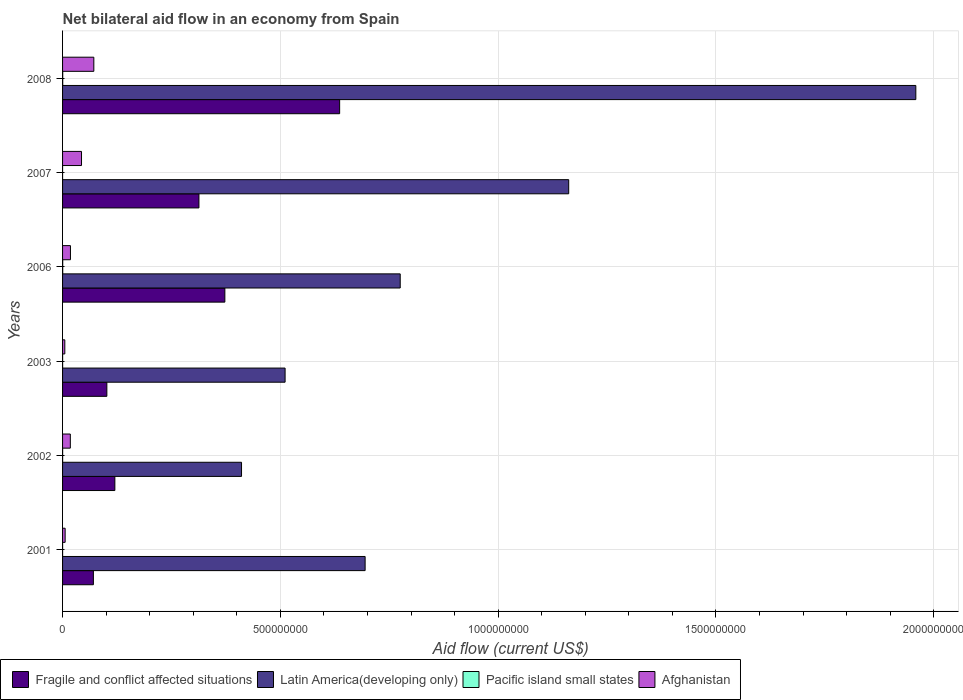How many groups of bars are there?
Give a very brief answer. 6. How many bars are there on the 2nd tick from the top?
Provide a succinct answer. 4. How many bars are there on the 5th tick from the bottom?
Make the answer very short. 4. In how many cases, is the number of bars for a given year not equal to the number of legend labels?
Keep it short and to the point. 0. What is the net bilateral aid flow in Pacific island small states in 2008?
Your response must be concise. 3.40e+05. Across all years, what is the maximum net bilateral aid flow in Afghanistan?
Ensure brevity in your answer.  7.18e+07. Across all years, what is the minimum net bilateral aid flow in Afghanistan?
Ensure brevity in your answer.  5.15e+06. In which year was the net bilateral aid flow in Pacific island small states maximum?
Make the answer very short. 2008. In which year was the net bilateral aid flow in Afghanistan minimum?
Give a very brief answer. 2003. What is the total net bilateral aid flow in Pacific island small states in the graph?
Give a very brief answer. 9.80e+05. What is the difference between the net bilateral aid flow in Afghanistan in 2001 and that in 2008?
Give a very brief answer. -6.59e+07. What is the difference between the net bilateral aid flow in Afghanistan in 2007 and the net bilateral aid flow in Fragile and conflict affected situations in 2003?
Offer a terse response. -5.82e+07. What is the average net bilateral aid flow in Latin America(developing only) per year?
Your response must be concise. 9.19e+08. In the year 2007, what is the difference between the net bilateral aid flow in Afghanistan and net bilateral aid flow in Pacific island small states?
Give a very brief answer. 4.35e+07. Is the net bilateral aid flow in Pacific island small states in 2003 less than that in 2008?
Make the answer very short. Yes. Is the difference between the net bilateral aid flow in Afghanistan in 2006 and 2007 greater than the difference between the net bilateral aid flow in Pacific island small states in 2006 and 2007?
Provide a short and direct response. No. What is the difference between the highest and the second highest net bilateral aid flow in Pacific island small states?
Keep it short and to the point. 10000. In how many years, is the net bilateral aid flow in Latin America(developing only) greater than the average net bilateral aid flow in Latin America(developing only) taken over all years?
Offer a terse response. 2. Is it the case that in every year, the sum of the net bilateral aid flow in Afghanistan and net bilateral aid flow in Pacific island small states is greater than the sum of net bilateral aid flow in Fragile and conflict affected situations and net bilateral aid flow in Latin America(developing only)?
Give a very brief answer. Yes. What does the 3rd bar from the top in 2007 represents?
Offer a terse response. Latin America(developing only). What does the 3rd bar from the bottom in 2001 represents?
Offer a very short reply. Pacific island small states. How many bars are there?
Make the answer very short. 24. How many years are there in the graph?
Offer a very short reply. 6. What is the difference between two consecutive major ticks on the X-axis?
Your response must be concise. 5.00e+08. Does the graph contain grids?
Ensure brevity in your answer.  Yes. What is the title of the graph?
Your response must be concise. Net bilateral aid flow in an economy from Spain. Does "High income: OECD" appear as one of the legend labels in the graph?
Your response must be concise. No. What is the Aid flow (current US$) in Fragile and conflict affected situations in 2001?
Keep it short and to the point. 7.08e+07. What is the Aid flow (current US$) in Latin America(developing only) in 2001?
Keep it short and to the point. 6.95e+08. What is the Aid flow (current US$) of Pacific island small states in 2001?
Your response must be concise. 5.00e+04. What is the Aid flow (current US$) of Afghanistan in 2001?
Provide a short and direct response. 5.92e+06. What is the Aid flow (current US$) in Fragile and conflict affected situations in 2002?
Your response must be concise. 1.20e+08. What is the Aid flow (current US$) in Latin America(developing only) in 2002?
Your response must be concise. 4.11e+08. What is the Aid flow (current US$) of Afghanistan in 2002?
Your answer should be very brief. 1.78e+07. What is the Aid flow (current US$) in Fragile and conflict affected situations in 2003?
Keep it short and to the point. 1.02e+08. What is the Aid flow (current US$) in Latin America(developing only) in 2003?
Your answer should be compact. 5.11e+08. What is the Aid flow (current US$) of Pacific island small states in 2003?
Make the answer very short. 1.00e+05. What is the Aid flow (current US$) in Afghanistan in 2003?
Keep it short and to the point. 5.15e+06. What is the Aid flow (current US$) of Fragile and conflict affected situations in 2006?
Your answer should be compact. 3.73e+08. What is the Aid flow (current US$) of Latin America(developing only) in 2006?
Make the answer very short. 7.75e+08. What is the Aid flow (current US$) in Pacific island small states in 2006?
Offer a very short reply. 3.30e+05. What is the Aid flow (current US$) in Afghanistan in 2006?
Your answer should be compact. 1.81e+07. What is the Aid flow (current US$) of Fragile and conflict affected situations in 2007?
Keep it short and to the point. 3.13e+08. What is the Aid flow (current US$) in Latin America(developing only) in 2007?
Give a very brief answer. 1.16e+09. What is the Aid flow (current US$) in Pacific island small states in 2007?
Make the answer very short. 10000. What is the Aid flow (current US$) in Afghanistan in 2007?
Your answer should be compact. 4.35e+07. What is the Aid flow (current US$) in Fragile and conflict affected situations in 2008?
Provide a short and direct response. 6.36e+08. What is the Aid flow (current US$) in Latin America(developing only) in 2008?
Your answer should be compact. 1.96e+09. What is the Aid flow (current US$) in Pacific island small states in 2008?
Your response must be concise. 3.40e+05. What is the Aid flow (current US$) in Afghanistan in 2008?
Provide a short and direct response. 7.18e+07. Across all years, what is the maximum Aid flow (current US$) in Fragile and conflict affected situations?
Make the answer very short. 6.36e+08. Across all years, what is the maximum Aid flow (current US$) in Latin America(developing only)?
Your answer should be very brief. 1.96e+09. Across all years, what is the maximum Aid flow (current US$) of Pacific island small states?
Give a very brief answer. 3.40e+05. Across all years, what is the maximum Aid flow (current US$) of Afghanistan?
Your response must be concise. 7.18e+07. Across all years, what is the minimum Aid flow (current US$) in Fragile and conflict affected situations?
Ensure brevity in your answer.  7.08e+07. Across all years, what is the minimum Aid flow (current US$) in Latin America(developing only)?
Keep it short and to the point. 4.11e+08. Across all years, what is the minimum Aid flow (current US$) of Afghanistan?
Offer a very short reply. 5.15e+06. What is the total Aid flow (current US$) of Fragile and conflict affected situations in the graph?
Make the answer very short. 1.61e+09. What is the total Aid flow (current US$) in Latin America(developing only) in the graph?
Offer a terse response. 5.51e+09. What is the total Aid flow (current US$) of Pacific island small states in the graph?
Provide a succinct answer. 9.80e+05. What is the total Aid flow (current US$) of Afghanistan in the graph?
Provide a succinct answer. 1.62e+08. What is the difference between the Aid flow (current US$) of Fragile and conflict affected situations in 2001 and that in 2002?
Give a very brief answer. -4.93e+07. What is the difference between the Aid flow (current US$) of Latin America(developing only) in 2001 and that in 2002?
Keep it short and to the point. 2.84e+08. What is the difference between the Aid flow (current US$) of Pacific island small states in 2001 and that in 2002?
Provide a succinct answer. -1.00e+05. What is the difference between the Aid flow (current US$) in Afghanistan in 2001 and that in 2002?
Your response must be concise. -1.19e+07. What is the difference between the Aid flow (current US$) in Fragile and conflict affected situations in 2001 and that in 2003?
Your answer should be compact. -3.09e+07. What is the difference between the Aid flow (current US$) in Latin America(developing only) in 2001 and that in 2003?
Your answer should be very brief. 1.84e+08. What is the difference between the Aid flow (current US$) of Pacific island small states in 2001 and that in 2003?
Offer a terse response. -5.00e+04. What is the difference between the Aid flow (current US$) in Afghanistan in 2001 and that in 2003?
Your answer should be compact. 7.70e+05. What is the difference between the Aid flow (current US$) in Fragile and conflict affected situations in 2001 and that in 2006?
Provide a short and direct response. -3.02e+08. What is the difference between the Aid flow (current US$) of Latin America(developing only) in 2001 and that in 2006?
Offer a very short reply. -8.06e+07. What is the difference between the Aid flow (current US$) of Pacific island small states in 2001 and that in 2006?
Offer a very short reply. -2.80e+05. What is the difference between the Aid flow (current US$) in Afghanistan in 2001 and that in 2006?
Give a very brief answer. -1.22e+07. What is the difference between the Aid flow (current US$) in Fragile and conflict affected situations in 2001 and that in 2007?
Your response must be concise. -2.42e+08. What is the difference between the Aid flow (current US$) in Latin America(developing only) in 2001 and that in 2007?
Your response must be concise. -4.67e+08. What is the difference between the Aid flow (current US$) in Afghanistan in 2001 and that in 2007?
Offer a very short reply. -3.76e+07. What is the difference between the Aid flow (current US$) of Fragile and conflict affected situations in 2001 and that in 2008?
Ensure brevity in your answer.  -5.65e+08. What is the difference between the Aid flow (current US$) in Latin America(developing only) in 2001 and that in 2008?
Your response must be concise. -1.26e+09. What is the difference between the Aid flow (current US$) in Afghanistan in 2001 and that in 2008?
Your answer should be compact. -6.59e+07. What is the difference between the Aid flow (current US$) in Fragile and conflict affected situations in 2002 and that in 2003?
Ensure brevity in your answer.  1.84e+07. What is the difference between the Aid flow (current US$) of Latin America(developing only) in 2002 and that in 2003?
Make the answer very short. -1.00e+08. What is the difference between the Aid flow (current US$) in Pacific island small states in 2002 and that in 2003?
Your answer should be compact. 5.00e+04. What is the difference between the Aid flow (current US$) in Afghanistan in 2002 and that in 2003?
Offer a terse response. 1.27e+07. What is the difference between the Aid flow (current US$) in Fragile and conflict affected situations in 2002 and that in 2006?
Make the answer very short. -2.53e+08. What is the difference between the Aid flow (current US$) in Latin America(developing only) in 2002 and that in 2006?
Keep it short and to the point. -3.64e+08. What is the difference between the Aid flow (current US$) of Afghanistan in 2002 and that in 2006?
Offer a terse response. -3.00e+05. What is the difference between the Aid flow (current US$) of Fragile and conflict affected situations in 2002 and that in 2007?
Keep it short and to the point. -1.93e+08. What is the difference between the Aid flow (current US$) in Latin America(developing only) in 2002 and that in 2007?
Keep it short and to the point. -7.51e+08. What is the difference between the Aid flow (current US$) in Pacific island small states in 2002 and that in 2007?
Provide a succinct answer. 1.40e+05. What is the difference between the Aid flow (current US$) in Afghanistan in 2002 and that in 2007?
Offer a very short reply. -2.57e+07. What is the difference between the Aid flow (current US$) of Fragile and conflict affected situations in 2002 and that in 2008?
Ensure brevity in your answer.  -5.16e+08. What is the difference between the Aid flow (current US$) in Latin America(developing only) in 2002 and that in 2008?
Keep it short and to the point. -1.55e+09. What is the difference between the Aid flow (current US$) of Afghanistan in 2002 and that in 2008?
Provide a short and direct response. -5.40e+07. What is the difference between the Aid flow (current US$) of Fragile and conflict affected situations in 2003 and that in 2006?
Ensure brevity in your answer.  -2.71e+08. What is the difference between the Aid flow (current US$) in Latin America(developing only) in 2003 and that in 2006?
Provide a succinct answer. -2.64e+08. What is the difference between the Aid flow (current US$) of Afghanistan in 2003 and that in 2006?
Provide a short and direct response. -1.30e+07. What is the difference between the Aid flow (current US$) in Fragile and conflict affected situations in 2003 and that in 2007?
Provide a succinct answer. -2.11e+08. What is the difference between the Aid flow (current US$) of Latin America(developing only) in 2003 and that in 2007?
Give a very brief answer. -6.51e+08. What is the difference between the Aid flow (current US$) of Afghanistan in 2003 and that in 2007?
Provide a short and direct response. -3.84e+07. What is the difference between the Aid flow (current US$) of Fragile and conflict affected situations in 2003 and that in 2008?
Make the answer very short. -5.34e+08. What is the difference between the Aid flow (current US$) in Latin America(developing only) in 2003 and that in 2008?
Offer a very short reply. -1.45e+09. What is the difference between the Aid flow (current US$) in Afghanistan in 2003 and that in 2008?
Provide a succinct answer. -6.66e+07. What is the difference between the Aid flow (current US$) of Fragile and conflict affected situations in 2006 and that in 2007?
Offer a very short reply. 5.95e+07. What is the difference between the Aid flow (current US$) in Latin America(developing only) in 2006 and that in 2007?
Offer a very short reply. -3.87e+08. What is the difference between the Aid flow (current US$) of Pacific island small states in 2006 and that in 2007?
Make the answer very short. 3.20e+05. What is the difference between the Aid flow (current US$) of Afghanistan in 2006 and that in 2007?
Your answer should be very brief. -2.54e+07. What is the difference between the Aid flow (current US$) in Fragile and conflict affected situations in 2006 and that in 2008?
Provide a succinct answer. -2.64e+08. What is the difference between the Aid flow (current US$) in Latin America(developing only) in 2006 and that in 2008?
Give a very brief answer. -1.18e+09. What is the difference between the Aid flow (current US$) of Pacific island small states in 2006 and that in 2008?
Provide a short and direct response. -10000. What is the difference between the Aid flow (current US$) of Afghanistan in 2006 and that in 2008?
Make the answer very short. -5.37e+07. What is the difference between the Aid flow (current US$) in Fragile and conflict affected situations in 2007 and that in 2008?
Keep it short and to the point. -3.23e+08. What is the difference between the Aid flow (current US$) in Latin America(developing only) in 2007 and that in 2008?
Provide a short and direct response. -7.97e+08. What is the difference between the Aid flow (current US$) in Pacific island small states in 2007 and that in 2008?
Give a very brief answer. -3.30e+05. What is the difference between the Aid flow (current US$) in Afghanistan in 2007 and that in 2008?
Provide a short and direct response. -2.83e+07. What is the difference between the Aid flow (current US$) of Fragile and conflict affected situations in 2001 and the Aid flow (current US$) of Latin America(developing only) in 2002?
Provide a short and direct response. -3.40e+08. What is the difference between the Aid flow (current US$) in Fragile and conflict affected situations in 2001 and the Aid flow (current US$) in Pacific island small states in 2002?
Provide a short and direct response. 7.06e+07. What is the difference between the Aid flow (current US$) of Fragile and conflict affected situations in 2001 and the Aid flow (current US$) of Afghanistan in 2002?
Your response must be concise. 5.30e+07. What is the difference between the Aid flow (current US$) in Latin America(developing only) in 2001 and the Aid flow (current US$) in Pacific island small states in 2002?
Your response must be concise. 6.95e+08. What is the difference between the Aid flow (current US$) of Latin America(developing only) in 2001 and the Aid flow (current US$) of Afghanistan in 2002?
Provide a succinct answer. 6.77e+08. What is the difference between the Aid flow (current US$) of Pacific island small states in 2001 and the Aid flow (current US$) of Afghanistan in 2002?
Keep it short and to the point. -1.78e+07. What is the difference between the Aid flow (current US$) of Fragile and conflict affected situations in 2001 and the Aid flow (current US$) of Latin America(developing only) in 2003?
Your answer should be compact. -4.40e+08. What is the difference between the Aid flow (current US$) of Fragile and conflict affected situations in 2001 and the Aid flow (current US$) of Pacific island small states in 2003?
Your response must be concise. 7.07e+07. What is the difference between the Aid flow (current US$) in Fragile and conflict affected situations in 2001 and the Aid flow (current US$) in Afghanistan in 2003?
Provide a succinct answer. 6.56e+07. What is the difference between the Aid flow (current US$) of Latin America(developing only) in 2001 and the Aid flow (current US$) of Pacific island small states in 2003?
Your response must be concise. 6.95e+08. What is the difference between the Aid flow (current US$) of Latin America(developing only) in 2001 and the Aid flow (current US$) of Afghanistan in 2003?
Provide a short and direct response. 6.90e+08. What is the difference between the Aid flow (current US$) in Pacific island small states in 2001 and the Aid flow (current US$) in Afghanistan in 2003?
Keep it short and to the point. -5.10e+06. What is the difference between the Aid flow (current US$) of Fragile and conflict affected situations in 2001 and the Aid flow (current US$) of Latin America(developing only) in 2006?
Provide a short and direct response. -7.04e+08. What is the difference between the Aid flow (current US$) in Fragile and conflict affected situations in 2001 and the Aid flow (current US$) in Pacific island small states in 2006?
Make the answer very short. 7.04e+07. What is the difference between the Aid flow (current US$) in Fragile and conflict affected situations in 2001 and the Aid flow (current US$) in Afghanistan in 2006?
Offer a terse response. 5.26e+07. What is the difference between the Aid flow (current US$) of Latin America(developing only) in 2001 and the Aid flow (current US$) of Pacific island small states in 2006?
Your answer should be very brief. 6.94e+08. What is the difference between the Aid flow (current US$) of Latin America(developing only) in 2001 and the Aid flow (current US$) of Afghanistan in 2006?
Give a very brief answer. 6.77e+08. What is the difference between the Aid flow (current US$) of Pacific island small states in 2001 and the Aid flow (current US$) of Afghanistan in 2006?
Your response must be concise. -1.81e+07. What is the difference between the Aid flow (current US$) of Fragile and conflict affected situations in 2001 and the Aid flow (current US$) of Latin America(developing only) in 2007?
Offer a terse response. -1.09e+09. What is the difference between the Aid flow (current US$) in Fragile and conflict affected situations in 2001 and the Aid flow (current US$) in Pacific island small states in 2007?
Ensure brevity in your answer.  7.08e+07. What is the difference between the Aid flow (current US$) of Fragile and conflict affected situations in 2001 and the Aid flow (current US$) of Afghanistan in 2007?
Provide a succinct answer. 2.73e+07. What is the difference between the Aid flow (current US$) in Latin America(developing only) in 2001 and the Aid flow (current US$) in Pacific island small states in 2007?
Give a very brief answer. 6.95e+08. What is the difference between the Aid flow (current US$) in Latin America(developing only) in 2001 and the Aid flow (current US$) in Afghanistan in 2007?
Ensure brevity in your answer.  6.51e+08. What is the difference between the Aid flow (current US$) of Pacific island small states in 2001 and the Aid flow (current US$) of Afghanistan in 2007?
Keep it short and to the point. -4.34e+07. What is the difference between the Aid flow (current US$) in Fragile and conflict affected situations in 2001 and the Aid flow (current US$) in Latin America(developing only) in 2008?
Offer a terse response. -1.89e+09. What is the difference between the Aid flow (current US$) of Fragile and conflict affected situations in 2001 and the Aid flow (current US$) of Pacific island small states in 2008?
Offer a very short reply. 7.04e+07. What is the difference between the Aid flow (current US$) in Fragile and conflict affected situations in 2001 and the Aid flow (current US$) in Afghanistan in 2008?
Provide a succinct answer. -1.03e+06. What is the difference between the Aid flow (current US$) of Latin America(developing only) in 2001 and the Aid flow (current US$) of Pacific island small states in 2008?
Ensure brevity in your answer.  6.94e+08. What is the difference between the Aid flow (current US$) in Latin America(developing only) in 2001 and the Aid flow (current US$) in Afghanistan in 2008?
Your response must be concise. 6.23e+08. What is the difference between the Aid flow (current US$) of Pacific island small states in 2001 and the Aid flow (current US$) of Afghanistan in 2008?
Provide a succinct answer. -7.17e+07. What is the difference between the Aid flow (current US$) of Fragile and conflict affected situations in 2002 and the Aid flow (current US$) of Latin America(developing only) in 2003?
Give a very brief answer. -3.91e+08. What is the difference between the Aid flow (current US$) in Fragile and conflict affected situations in 2002 and the Aid flow (current US$) in Pacific island small states in 2003?
Ensure brevity in your answer.  1.20e+08. What is the difference between the Aid flow (current US$) in Fragile and conflict affected situations in 2002 and the Aid flow (current US$) in Afghanistan in 2003?
Ensure brevity in your answer.  1.15e+08. What is the difference between the Aid flow (current US$) of Latin America(developing only) in 2002 and the Aid flow (current US$) of Pacific island small states in 2003?
Offer a terse response. 4.11e+08. What is the difference between the Aid flow (current US$) of Latin America(developing only) in 2002 and the Aid flow (current US$) of Afghanistan in 2003?
Provide a succinct answer. 4.06e+08. What is the difference between the Aid flow (current US$) in Pacific island small states in 2002 and the Aid flow (current US$) in Afghanistan in 2003?
Give a very brief answer. -5.00e+06. What is the difference between the Aid flow (current US$) of Fragile and conflict affected situations in 2002 and the Aid flow (current US$) of Latin America(developing only) in 2006?
Your answer should be very brief. -6.55e+08. What is the difference between the Aid flow (current US$) in Fragile and conflict affected situations in 2002 and the Aid flow (current US$) in Pacific island small states in 2006?
Give a very brief answer. 1.20e+08. What is the difference between the Aid flow (current US$) in Fragile and conflict affected situations in 2002 and the Aid flow (current US$) in Afghanistan in 2006?
Offer a very short reply. 1.02e+08. What is the difference between the Aid flow (current US$) of Latin America(developing only) in 2002 and the Aid flow (current US$) of Pacific island small states in 2006?
Provide a short and direct response. 4.11e+08. What is the difference between the Aid flow (current US$) of Latin America(developing only) in 2002 and the Aid flow (current US$) of Afghanistan in 2006?
Keep it short and to the point. 3.93e+08. What is the difference between the Aid flow (current US$) of Pacific island small states in 2002 and the Aid flow (current US$) of Afghanistan in 2006?
Your answer should be very brief. -1.80e+07. What is the difference between the Aid flow (current US$) of Fragile and conflict affected situations in 2002 and the Aid flow (current US$) of Latin America(developing only) in 2007?
Offer a terse response. -1.04e+09. What is the difference between the Aid flow (current US$) in Fragile and conflict affected situations in 2002 and the Aid flow (current US$) in Pacific island small states in 2007?
Provide a short and direct response. 1.20e+08. What is the difference between the Aid flow (current US$) in Fragile and conflict affected situations in 2002 and the Aid flow (current US$) in Afghanistan in 2007?
Offer a very short reply. 7.66e+07. What is the difference between the Aid flow (current US$) in Latin America(developing only) in 2002 and the Aid flow (current US$) in Pacific island small states in 2007?
Your response must be concise. 4.11e+08. What is the difference between the Aid flow (current US$) in Latin America(developing only) in 2002 and the Aid flow (current US$) in Afghanistan in 2007?
Your answer should be compact. 3.67e+08. What is the difference between the Aid flow (current US$) of Pacific island small states in 2002 and the Aid flow (current US$) of Afghanistan in 2007?
Provide a short and direct response. -4.34e+07. What is the difference between the Aid flow (current US$) in Fragile and conflict affected situations in 2002 and the Aid flow (current US$) in Latin America(developing only) in 2008?
Make the answer very short. -1.84e+09. What is the difference between the Aid flow (current US$) of Fragile and conflict affected situations in 2002 and the Aid flow (current US$) of Pacific island small states in 2008?
Provide a succinct answer. 1.20e+08. What is the difference between the Aid flow (current US$) in Fragile and conflict affected situations in 2002 and the Aid flow (current US$) in Afghanistan in 2008?
Offer a terse response. 4.83e+07. What is the difference between the Aid flow (current US$) of Latin America(developing only) in 2002 and the Aid flow (current US$) of Pacific island small states in 2008?
Provide a short and direct response. 4.11e+08. What is the difference between the Aid flow (current US$) of Latin America(developing only) in 2002 and the Aid flow (current US$) of Afghanistan in 2008?
Provide a short and direct response. 3.39e+08. What is the difference between the Aid flow (current US$) in Pacific island small states in 2002 and the Aid flow (current US$) in Afghanistan in 2008?
Provide a short and direct response. -7.16e+07. What is the difference between the Aid flow (current US$) of Fragile and conflict affected situations in 2003 and the Aid flow (current US$) of Latin America(developing only) in 2006?
Your response must be concise. -6.74e+08. What is the difference between the Aid flow (current US$) in Fragile and conflict affected situations in 2003 and the Aid flow (current US$) in Pacific island small states in 2006?
Make the answer very short. 1.01e+08. What is the difference between the Aid flow (current US$) in Fragile and conflict affected situations in 2003 and the Aid flow (current US$) in Afghanistan in 2006?
Keep it short and to the point. 8.36e+07. What is the difference between the Aid flow (current US$) in Latin America(developing only) in 2003 and the Aid flow (current US$) in Pacific island small states in 2006?
Keep it short and to the point. 5.11e+08. What is the difference between the Aid flow (current US$) in Latin America(developing only) in 2003 and the Aid flow (current US$) in Afghanistan in 2006?
Your answer should be compact. 4.93e+08. What is the difference between the Aid flow (current US$) in Pacific island small states in 2003 and the Aid flow (current US$) in Afghanistan in 2006?
Ensure brevity in your answer.  -1.80e+07. What is the difference between the Aid flow (current US$) of Fragile and conflict affected situations in 2003 and the Aid flow (current US$) of Latin America(developing only) in 2007?
Provide a succinct answer. -1.06e+09. What is the difference between the Aid flow (current US$) in Fragile and conflict affected situations in 2003 and the Aid flow (current US$) in Pacific island small states in 2007?
Keep it short and to the point. 1.02e+08. What is the difference between the Aid flow (current US$) of Fragile and conflict affected situations in 2003 and the Aid flow (current US$) of Afghanistan in 2007?
Make the answer very short. 5.82e+07. What is the difference between the Aid flow (current US$) in Latin America(developing only) in 2003 and the Aid flow (current US$) in Pacific island small states in 2007?
Make the answer very short. 5.11e+08. What is the difference between the Aid flow (current US$) of Latin America(developing only) in 2003 and the Aid flow (current US$) of Afghanistan in 2007?
Ensure brevity in your answer.  4.67e+08. What is the difference between the Aid flow (current US$) of Pacific island small states in 2003 and the Aid flow (current US$) of Afghanistan in 2007?
Your response must be concise. -4.34e+07. What is the difference between the Aid flow (current US$) in Fragile and conflict affected situations in 2003 and the Aid flow (current US$) in Latin America(developing only) in 2008?
Your answer should be compact. -1.86e+09. What is the difference between the Aid flow (current US$) in Fragile and conflict affected situations in 2003 and the Aid flow (current US$) in Pacific island small states in 2008?
Your answer should be compact. 1.01e+08. What is the difference between the Aid flow (current US$) of Fragile and conflict affected situations in 2003 and the Aid flow (current US$) of Afghanistan in 2008?
Your answer should be compact. 2.99e+07. What is the difference between the Aid flow (current US$) of Latin America(developing only) in 2003 and the Aid flow (current US$) of Pacific island small states in 2008?
Provide a short and direct response. 5.11e+08. What is the difference between the Aid flow (current US$) of Latin America(developing only) in 2003 and the Aid flow (current US$) of Afghanistan in 2008?
Your response must be concise. 4.39e+08. What is the difference between the Aid flow (current US$) in Pacific island small states in 2003 and the Aid flow (current US$) in Afghanistan in 2008?
Provide a short and direct response. -7.17e+07. What is the difference between the Aid flow (current US$) in Fragile and conflict affected situations in 2006 and the Aid flow (current US$) in Latin America(developing only) in 2007?
Your answer should be compact. -7.89e+08. What is the difference between the Aid flow (current US$) of Fragile and conflict affected situations in 2006 and the Aid flow (current US$) of Pacific island small states in 2007?
Make the answer very short. 3.73e+08. What is the difference between the Aid flow (current US$) in Fragile and conflict affected situations in 2006 and the Aid flow (current US$) in Afghanistan in 2007?
Ensure brevity in your answer.  3.29e+08. What is the difference between the Aid flow (current US$) in Latin America(developing only) in 2006 and the Aid flow (current US$) in Pacific island small states in 2007?
Your response must be concise. 7.75e+08. What is the difference between the Aid flow (current US$) in Latin America(developing only) in 2006 and the Aid flow (current US$) in Afghanistan in 2007?
Provide a short and direct response. 7.32e+08. What is the difference between the Aid flow (current US$) in Pacific island small states in 2006 and the Aid flow (current US$) in Afghanistan in 2007?
Your answer should be very brief. -4.32e+07. What is the difference between the Aid flow (current US$) of Fragile and conflict affected situations in 2006 and the Aid flow (current US$) of Latin America(developing only) in 2008?
Give a very brief answer. -1.59e+09. What is the difference between the Aid flow (current US$) of Fragile and conflict affected situations in 2006 and the Aid flow (current US$) of Pacific island small states in 2008?
Offer a terse response. 3.72e+08. What is the difference between the Aid flow (current US$) of Fragile and conflict affected situations in 2006 and the Aid flow (current US$) of Afghanistan in 2008?
Your answer should be very brief. 3.01e+08. What is the difference between the Aid flow (current US$) in Latin America(developing only) in 2006 and the Aid flow (current US$) in Pacific island small states in 2008?
Your answer should be compact. 7.75e+08. What is the difference between the Aid flow (current US$) in Latin America(developing only) in 2006 and the Aid flow (current US$) in Afghanistan in 2008?
Your response must be concise. 7.03e+08. What is the difference between the Aid flow (current US$) of Pacific island small states in 2006 and the Aid flow (current US$) of Afghanistan in 2008?
Your answer should be very brief. -7.15e+07. What is the difference between the Aid flow (current US$) of Fragile and conflict affected situations in 2007 and the Aid flow (current US$) of Latin America(developing only) in 2008?
Your response must be concise. -1.65e+09. What is the difference between the Aid flow (current US$) in Fragile and conflict affected situations in 2007 and the Aid flow (current US$) in Pacific island small states in 2008?
Offer a terse response. 3.13e+08. What is the difference between the Aid flow (current US$) of Fragile and conflict affected situations in 2007 and the Aid flow (current US$) of Afghanistan in 2008?
Make the answer very short. 2.41e+08. What is the difference between the Aid flow (current US$) in Latin America(developing only) in 2007 and the Aid flow (current US$) in Pacific island small states in 2008?
Your answer should be compact. 1.16e+09. What is the difference between the Aid flow (current US$) of Latin America(developing only) in 2007 and the Aid flow (current US$) of Afghanistan in 2008?
Make the answer very short. 1.09e+09. What is the difference between the Aid flow (current US$) in Pacific island small states in 2007 and the Aid flow (current US$) in Afghanistan in 2008?
Give a very brief answer. -7.18e+07. What is the average Aid flow (current US$) of Fragile and conflict affected situations per year?
Your response must be concise. 2.69e+08. What is the average Aid flow (current US$) in Latin America(developing only) per year?
Ensure brevity in your answer.  9.19e+08. What is the average Aid flow (current US$) in Pacific island small states per year?
Offer a very short reply. 1.63e+05. What is the average Aid flow (current US$) of Afghanistan per year?
Your answer should be compact. 2.70e+07. In the year 2001, what is the difference between the Aid flow (current US$) of Fragile and conflict affected situations and Aid flow (current US$) of Latin America(developing only)?
Your response must be concise. -6.24e+08. In the year 2001, what is the difference between the Aid flow (current US$) of Fragile and conflict affected situations and Aid flow (current US$) of Pacific island small states?
Keep it short and to the point. 7.07e+07. In the year 2001, what is the difference between the Aid flow (current US$) of Fragile and conflict affected situations and Aid flow (current US$) of Afghanistan?
Make the answer very short. 6.48e+07. In the year 2001, what is the difference between the Aid flow (current US$) of Latin America(developing only) and Aid flow (current US$) of Pacific island small states?
Keep it short and to the point. 6.95e+08. In the year 2001, what is the difference between the Aid flow (current US$) of Latin America(developing only) and Aid flow (current US$) of Afghanistan?
Your answer should be compact. 6.89e+08. In the year 2001, what is the difference between the Aid flow (current US$) in Pacific island small states and Aid flow (current US$) in Afghanistan?
Your answer should be compact. -5.87e+06. In the year 2002, what is the difference between the Aid flow (current US$) in Fragile and conflict affected situations and Aid flow (current US$) in Latin America(developing only)?
Offer a terse response. -2.91e+08. In the year 2002, what is the difference between the Aid flow (current US$) in Fragile and conflict affected situations and Aid flow (current US$) in Pacific island small states?
Offer a very short reply. 1.20e+08. In the year 2002, what is the difference between the Aid flow (current US$) in Fragile and conflict affected situations and Aid flow (current US$) in Afghanistan?
Keep it short and to the point. 1.02e+08. In the year 2002, what is the difference between the Aid flow (current US$) of Latin America(developing only) and Aid flow (current US$) of Pacific island small states?
Make the answer very short. 4.11e+08. In the year 2002, what is the difference between the Aid flow (current US$) of Latin America(developing only) and Aid flow (current US$) of Afghanistan?
Keep it short and to the point. 3.93e+08. In the year 2002, what is the difference between the Aid flow (current US$) of Pacific island small states and Aid flow (current US$) of Afghanistan?
Offer a very short reply. -1.77e+07. In the year 2003, what is the difference between the Aid flow (current US$) of Fragile and conflict affected situations and Aid flow (current US$) of Latin America(developing only)?
Offer a very short reply. -4.09e+08. In the year 2003, what is the difference between the Aid flow (current US$) in Fragile and conflict affected situations and Aid flow (current US$) in Pacific island small states?
Your answer should be very brief. 1.02e+08. In the year 2003, what is the difference between the Aid flow (current US$) of Fragile and conflict affected situations and Aid flow (current US$) of Afghanistan?
Provide a short and direct response. 9.65e+07. In the year 2003, what is the difference between the Aid flow (current US$) in Latin America(developing only) and Aid flow (current US$) in Pacific island small states?
Provide a short and direct response. 5.11e+08. In the year 2003, what is the difference between the Aid flow (current US$) in Latin America(developing only) and Aid flow (current US$) in Afghanistan?
Give a very brief answer. 5.06e+08. In the year 2003, what is the difference between the Aid flow (current US$) of Pacific island small states and Aid flow (current US$) of Afghanistan?
Provide a succinct answer. -5.05e+06. In the year 2006, what is the difference between the Aid flow (current US$) in Fragile and conflict affected situations and Aid flow (current US$) in Latin America(developing only)?
Offer a terse response. -4.03e+08. In the year 2006, what is the difference between the Aid flow (current US$) in Fragile and conflict affected situations and Aid flow (current US$) in Pacific island small states?
Offer a very short reply. 3.72e+08. In the year 2006, what is the difference between the Aid flow (current US$) in Fragile and conflict affected situations and Aid flow (current US$) in Afghanistan?
Provide a succinct answer. 3.55e+08. In the year 2006, what is the difference between the Aid flow (current US$) of Latin America(developing only) and Aid flow (current US$) of Pacific island small states?
Provide a short and direct response. 7.75e+08. In the year 2006, what is the difference between the Aid flow (current US$) in Latin America(developing only) and Aid flow (current US$) in Afghanistan?
Your response must be concise. 7.57e+08. In the year 2006, what is the difference between the Aid flow (current US$) of Pacific island small states and Aid flow (current US$) of Afghanistan?
Offer a terse response. -1.78e+07. In the year 2007, what is the difference between the Aid flow (current US$) in Fragile and conflict affected situations and Aid flow (current US$) in Latin America(developing only)?
Provide a succinct answer. -8.49e+08. In the year 2007, what is the difference between the Aid flow (current US$) in Fragile and conflict affected situations and Aid flow (current US$) in Pacific island small states?
Give a very brief answer. 3.13e+08. In the year 2007, what is the difference between the Aid flow (current US$) in Fragile and conflict affected situations and Aid flow (current US$) in Afghanistan?
Give a very brief answer. 2.70e+08. In the year 2007, what is the difference between the Aid flow (current US$) of Latin America(developing only) and Aid flow (current US$) of Pacific island small states?
Provide a succinct answer. 1.16e+09. In the year 2007, what is the difference between the Aid flow (current US$) in Latin America(developing only) and Aid flow (current US$) in Afghanistan?
Your response must be concise. 1.12e+09. In the year 2007, what is the difference between the Aid flow (current US$) of Pacific island small states and Aid flow (current US$) of Afghanistan?
Ensure brevity in your answer.  -4.35e+07. In the year 2008, what is the difference between the Aid flow (current US$) of Fragile and conflict affected situations and Aid flow (current US$) of Latin America(developing only)?
Provide a short and direct response. -1.32e+09. In the year 2008, what is the difference between the Aid flow (current US$) of Fragile and conflict affected situations and Aid flow (current US$) of Pacific island small states?
Your response must be concise. 6.36e+08. In the year 2008, what is the difference between the Aid flow (current US$) of Fragile and conflict affected situations and Aid flow (current US$) of Afghanistan?
Your answer should be compact. 5.64e+08. In the year 2008, what is the difference between the Aid flow (current US$) in Latin America(developing only) and Aid flow (current US$) in Pacific island small states?
Your response must be concise. 1.96e+09. In the year 2008, what is the difference between the Aid flow (current US$) in Latin America(developing only) and Aid flow (current US$) in Afghanistan?
Ensure brevity in your answer.  1.89e+09. In the year 2008, what is the difference between the Aid flow (current US$) of Pacific island small states and Aid flow (current US$) of Afghanistan?
Offer a terse response. -7.14e+07. What is the ratio of the Aid flow (current US$) of Fragile and conflict affected situations in 2001 to that in 2002?
Your response must be concise. 0.59. What is the ratio of the Aid flow (current US$) in Latin America(developing only) in 2001 to that in 2002?
Your response must be concise. 1.69. What is the ratio of the Aid flow (current US$) of Pacific island small states in 2001 to that in 2002?
Make the answer very short. 0.33. What is the ratio of the Aid flow (current US$) in Afghanistan in 2001 to that in 2002?
Provide a short and direct response. 0.33. What is the ratio of the Aid flow (current US$) in Fragile and conflict affected situations in 2001 to that in 2003?
Provide a succinct answer. 0.7. What is the ratio of the Aid flow (current US$) of Latin America(developing only) in 2001 to that in 2003?
Make the answer very short. 1.36. What is the ratio of the Aid flow (current US$) of Pacific island small states in 2001 to that in 2003?
Keep it short and to the point. 0.5. What is the ratio of the Aid flow (current US$) of Afghanistan in 2001 to that in 2003?
Keep it short and to the point. 1.15. What is the ratio of the Aid flow (current US$) of Fragile and conflict affected situations in 2001 to that in 2006?
Ensure brevity in your answer.  0.19. What is the ratio of the Aid flow (current US$) in Latin America(developing only) in 2001 to that in 2006?
Make the answer very short. 0.9. What is the ratio of the Aid flow (current US$) in Pacific island small states in 2001 to that in 2006?
Your response must be concise. 0.15. What is the ratio of the Aid flow (current US$) in Afghanistan in 2001 to that in 2006?
Your answer should be compact. 0.33. What is the ratio of the Aid flow (current US$) in Fragile and conflict affected situations in 2001 to that in 2007?
Give a very brief answer. 0.23. What is the ratio of the Aid flow (current US$) of Latin America(developing only) in 2001 to that in 2007?
Your response must be concise. 0.6. What is the ratio of the Aid flow (current US$) in Afghanistan in 2001 to that in 2007?
Offer a very short reply. 0.14. What is the ratio of the Aid flow (current US$) in Fragile and conflict affected situations in 2001 to that in 2008?
Provide a short and direct response. 0.11. What is the ratio of the Aid flow (current US$) of Latin America(developing only) in 2001 to that in 2008?
Offer a very short reply. 0.35. What is the ratio of the Aid flow (current US$) in Pacific island small states in 2001 to that in 2008?
Your response must be concise. 0.15. What is the ratio of the Aid flow (current US$) in Afghanistan in 2001 to that in 2008?
Your answer should be compact. 0.08. What is the ratio of the Aid flow (current US$) of Fragile and conflict affected situations in 2002 to that in 2003?
Offer a very short reply. 1.18. What is the ratio of the Aid flow (current US$) of Latin America(developing only) in 2002 to that in 2003?
Your answer should be very brief. 0.8. What is the ratio of the Aid flow (current US$) of Afghanistan in 2002 to that in 2003?
Make the answer very short. 3.46. What is the ratio of the Aid flow (current US$) of Fragile and conflict affected situations in 2002 to that in 2006?
Provide a succinct answer. 0.32. What is the ratio of the Aid flow (current US$) in Latin America(developing only) in 2002 to that in 2006?
Provide a short and direct response. 0.53. What is the ratio of the Aid flow (current US$) in Pacific island small states in 2002 to that in 2006?
Provide a succinct answer. 0.45. What is the ratio of the Aid flow (current US$) in Afghanistan in 2002 to that in 2006?
Your answer should be compact. 0.98. What is the ratio of the Aid flow (current US$) of Fragile and conflict affected situations in 2002 to that in 2007?
Your answer should be very brief. 0.38. What is the ratio of the Aid flow (current US$) of Latin America(developing only) in 2002 to that in 2007?
Provide a succinct answer. 0.35. What is the ratio of the Aid flow (current US$) of Afghanistan in 2002 to that in 2007?
Provide a succinct answer. 0.41. What is the ratio of the Aid flow (current US$) in Fragile and conflict affected situations in 2002 to that in 2008?
Ensure brevity in your answer.  0.19. What is the ratio of the Aid flow (current US$) of Latin America(developing only) in 2002 to that in 2008?
Make the answer very short. 0.21. What is the ratio of the Aid flow (current US$) of Pacific island small states in 2002 to that in 2008?
Ensure brevity in your answer.  0.44. What is the ratio of the Aid flow (current US$) in Afghanistan in 2002 to that in 2008?
Offer a very short reply. 0.25. What is the ratio of the Aid flow (current US$) in Fragile and conflict affected situations in 2003 to that in 2006?
Provide a short and direct response. 0.27. What is the ratio of the Aid flow (current US$) of Latin America(developing only) in 2003 to that in 2006?
Your answer should be compact. 0.66. What is the ratio of the Aid flow (current US$) of Pacific island small states in 2003 to that in 2006?
Provide a succinct answer. 0.3. What is the ratio of the Aid flow (current US$) of Afghanistan in 2003 to that in 2006?
Provide a short and direct response. 0.28. What is the ratio of the Aid flow (current US$) in Fragile and conflict affected situations in 2003 to that in 2007?
Keep it short and to the point. 0.32. What is the ratio of the Aid flow (current US$) of Latin America(developing only) in 2003 to that in 2007?
Provide a short and direct response. 0.44. What is the ratio of the Aid flow (current US$) of Pacific island small states in 2003 to that in 2007?
Give a very brief answer. 10. What is the ratio of the Aid flow (current US$) of Afghanistan in 2003 to that in 2007?
Ensure brevity in your answer.  0.12. What is the ratio of the Aid flow (current US$) of Fragile and conflict affected situations in 2003 to that in 2008?
Offer a very short reply. 0.16. What is the ratio of the Aid flow (current US$) in Latin America(developing only) in 2003 to that in 2008?
Keep it short and to the point. 0.26. What is the ratio of the Aid flow (current US$) in Pacific island small states in 2003 to that in 2008?
Ensure brevity in your answer.  0.29. What is the ratio of the Aid flow (current US$) in Afghanistan in 2003 to that in 2008?
Offer a terse response. 0.07. What is the ratio of the Aid flow (current US$) of Fragile and conflict affected situations in 2006 to that in 2007?
Provide a succinct answer. 1.19. What is the ratio of the Aid flow (current US$) in Latin America(developing only) in 2006 to that in 2007?
Offer a terse response. 0.67. What is the ratio of the Aid flow (current US$) in Pacific island small states in 2006 to that in 2007?
Make the answer very short. 33. What is the ratio of the Aid flow (current US$) in Afghanistan in 2006 to that in 2007?
Your response must be concise. 0.42. What is the ratio of the Aid flow (current US$) in Fragile and conflict affected situations in 2006 to that in 2008?
Give a very brief answer. 0.59. What is the ratio of the Aid flow (current US$) of Latin America(developing only) in 2006 to that in 2008?
Provide a succinct answer. 0.4. What is the ratio of the Aid flow (current US$) in Pacific island small states in 2006 to that in 2008?
Make the answer very short. 0.97. What is the ratio of the Aid flow (current US$) of Afghanistan in 2006 to that in 2008?
Your answer should be compact. 0.25. What is the ratio of the Aid flow (current US$) in Fragile and conflict affected situations in 2007 to that in 2008?
Your response must be concise. 0.49. What is the ratio of the Aid flow (current US$) in Latin America(developing only) in 2007 to that in 2008?
Make the answer very short. 0.59. What is the ratio of the Aid flow (current US$) of Pacific island small states in 2007 to that in 2008?
Your answer should be very brief. 0.03. What is the ratio of the Aid flow (current US$) of Afghanistan in 2007 to that in 2008?
Your response must be concise. 0.61. What is the difference between the highest and the second highest Aid flow (current US$) in Fragile and conflict affected situations?
Your answer should be very brief. 2.64e+08. What is the difference between the highest and the second highest Aid flow (current US$) in Latin America(developing only)?
Make the answer very short. 7.97e+08. What is the difference between the highest and the second highest Aid flow (current US$) in Afghanistan?
Provide a succinct answer. 2.83e+07. What is the difference between the highest and the lowest Aid flow (current US$) of Fragile and conflict affected situations?
Your answer should be very brief. 5.65e+08. What is the difference between the highest and the lowest Aid flow (current US$) of Latin America(developing only)?
Offer a terse response. 1.55e+09. What is the difference between the highest and the lowest Aid flow (current US$) of Afghanistan?
Provide a short and direct response. 6.66e+07. 